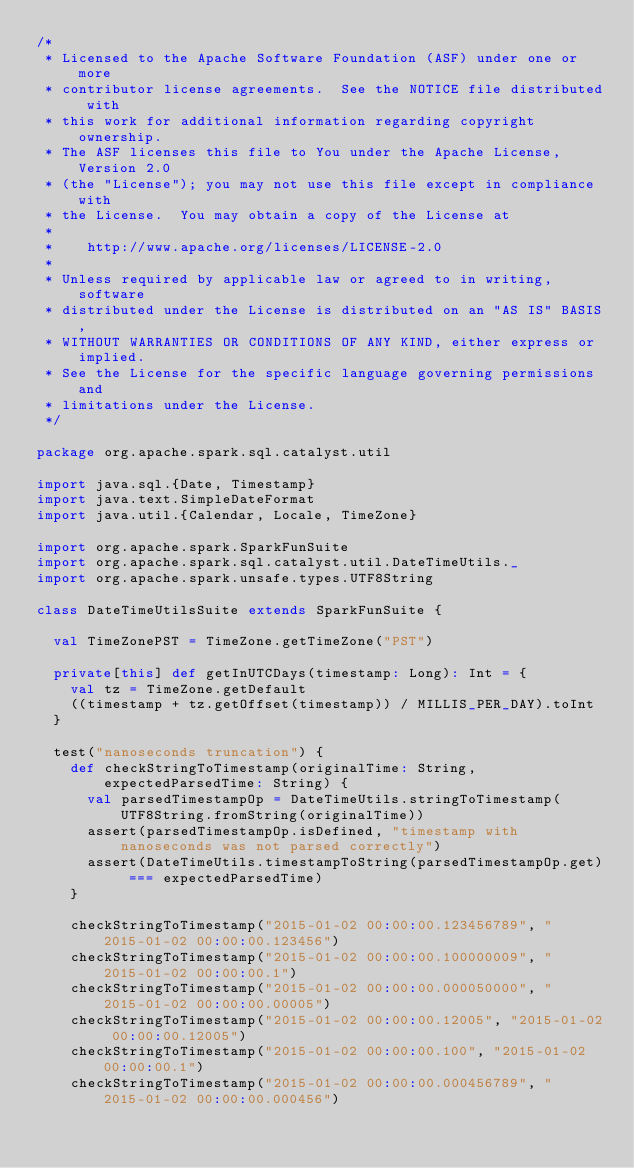Convert code to text. <code><loc_0><loc_0><loc_500><loc_500><_Scala_>/*
 * Licensed to the Apache Software Foundation (ASF) under one or more
 * contributor license agreements.  See the NOTICE file distributed with
 * this work for additional information regarding copyright ownership.
 * The ASF licenses this file to You under the Apache License, Version 2.0
 * (the "License"); you may not use this file except in compliance with
 * the License.  You may obtain a copy of the License at
 *
 *    http://www.apache.org/licenses/LICENSE-2.0
 *
 * Unless required by applicable law or agreed to in writing, software
 * distributed under the License is distributed on an "AS IS" BASIS,
 * WITHOUT WARRANTIES OR CONDITIONS OF ANY KIND, either express or implied.
 * See the License for the specific language governing permissions and
 * limitations under the License.
 */

package org.apache.spark.sql.catalyst.util

import java.sql.{Date, Timestamp}
import java.text.SimpleDateFormat
import java.util.{Calendar, Locale, TimeZone}

import org.apache.spark.SparkFunSuite
import org.apache.spark.sql.catalyst.util.DateTimeUtils._
import org.apache.spark.unsafe.types.UTF8String

class DateTimeUtilsSuite extends SparkFunSuite {

  val TimeZonePST = TimeZone.getTimeZone("PST")

  private[this] def getInUTCDays(timestamp: Long): Int = {
    val tz = TimeZone.getDefault
    ((timestamp + tz.getOffset(timestamp)) / MILLIS_PER_DAY).toInt
  }

  test("nanoseconds truncation") {
    def checkStringToTimestamp(originalTime: String, expectedParsedTime: String) {
      val parsedTimestampOp = DateTimeUtils.stringToTimestamp(UTF8String.fromString(originalTime))
      assert(parsedTimestampOp.isDefined, "timestamp with nanoseconds was not parsed correctly")
      assert(DateTimeUtils.timestampToString(parsedTimestampOp.get) === expectedParsedTime)
    }

    checkStringToTimestamp("2015-01-02 00:00:00.123456789", "2015-01-02 00:00:00.123456")
    checkStringToTimestamp("2015-01-02 00:00:00.100000009", "2015-01-02 00:00:00.1")
    checkStringToTimestamp("2015-01-02 00:00:00.000050000", "2015-01-02 00:00:00.00005")
    checkStringToTimestamp("2015-01-02 00:00:00.12005", "2015-01-02 00:00:00.12005")
    checkStringToTimestamp("2015-01-02 00:00:00.100", "2015-01-02 00:00:00.1")
    checkStringToTimestamp("2015-01-02 00:00:00.000456789", "2015-01-02 00:00:00.000456")</code> 